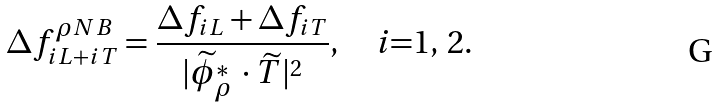<formula> <loc_0><loc_0><loc_500><loc_500>\Delta f ^ { \rho N B } _ { i L + i T } = \frac { \Delta f _ { i L } + \Delta f _ { i T } } { | \widetilde { \phi } _ { \rho } ^ { * } \, \cdot \widetilde { T } | ^ { 2 } } , \quad \text {$i$=1, 2} .</formula> 